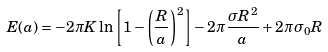Convert formula to latex. <formula><loc_0><loc_0><loc_500><loc_500>E ( a ) = - 2 \pi K \ln \left [ 1 - \left ( \frac { R } { a } \right ) ^ { 2 } \right ] - 2 \pi \frac { \sigma R ^ { 2 } } { a } + 2 \pi \sigma _ { 0 } R</formula> 